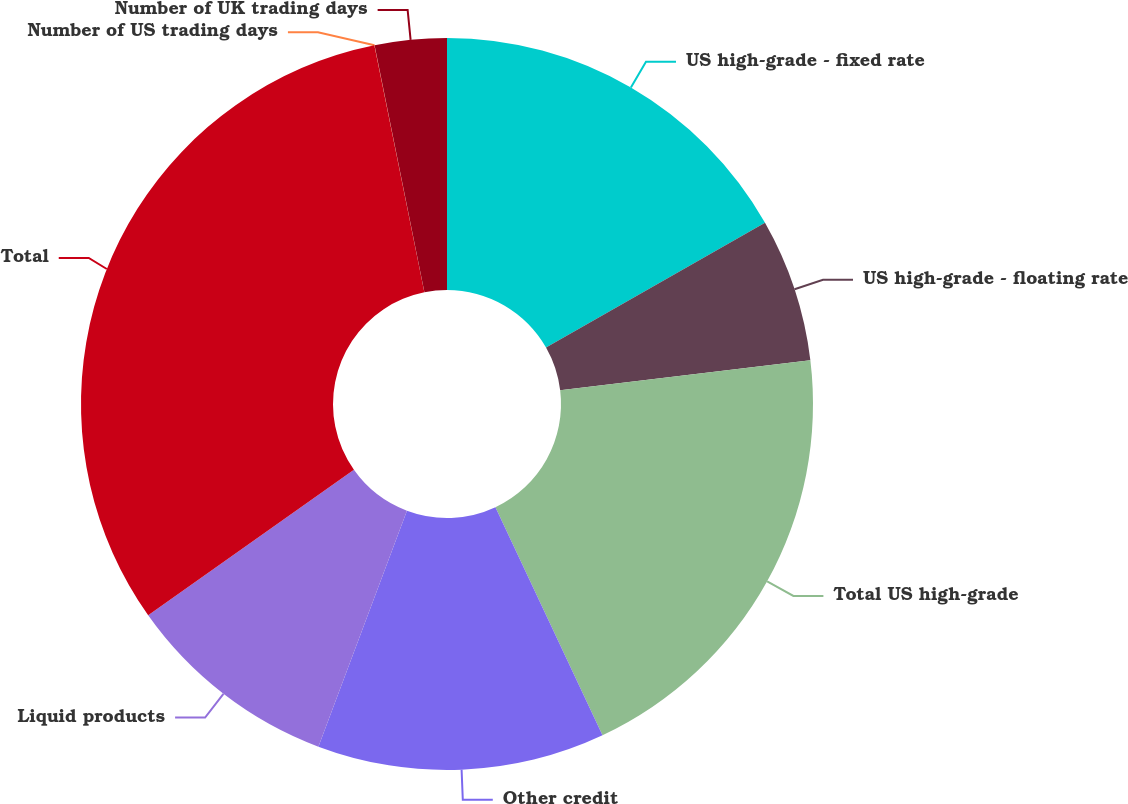Convert chart to OTSL. <chart><loc_0><loc_0><loc_500><loc_500><pie_chart><fcel>US high-grade - fixed rate<fcel>US high-grade - floating rate<fcel>Total US high-grade<fcel>Other credit<fcel>Liquid products<fcel>Total<fcel>Number of US trading days<fcel>Number of UK trading days<nl><fcel>16.76%<fcel>6.33%<fcel>19.93%<fcel>12.7%<fcel>9.49%<fcel>31.62%<fcel>0.01%<fcel>3.17%<nl></chart> 